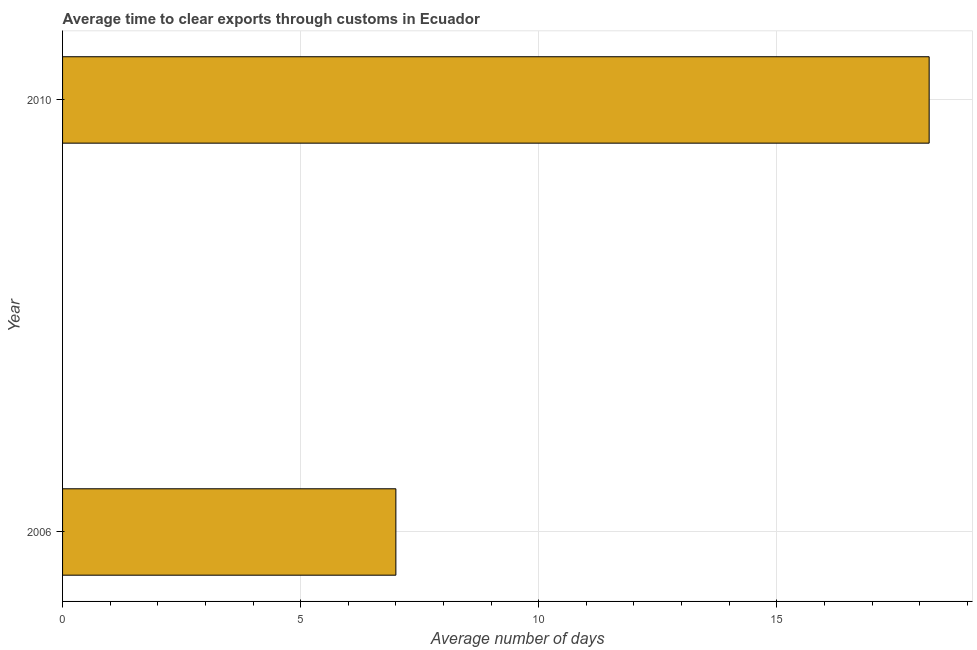Does the graph contain any zero values?
Make the answer very short. No. What is the title of the graph?
Keep it short and to the point. Average time to clear exports through customs in Ecuador. What is the label or title of the X-axis?
Give a very brief answer. Average number of days. Across all years, what is the maximum time to clear exports through customs?
Your answer should be compact. 18.2. In which year was the time to clear exports through customs minimum?
Make the answer very short. 2006. What is the sum of the time to clear exports through customs?
Provide a short and direct response. 25.2. What is the median time to clear exports through customs?
Your response must be concise. 12.6. In how many years, is the time to clear exports through customs greater than 16 days?
Give a very brief answer. 1. What is the ratio of the time to clear exports through customs in 2006 to that in 2010?
Provide a short and direct response. 0.39. Is the time to clear exports through customs in 2006 less than that in 2010?
Provide a succinct answer. Yes. How many bars are there?
Offer a very short reply. 2. What is the difference between two consecutive major ticks on the X-axis?
Offer a terse response. 5. Are the values on the major ticks of X-axis written in scientific E-notation?
Offer a very short reply. No. What is the Average number of days of 2006?
Offer a terse response. 7. What is the Average number of days in 2010?
Ensure brevity in your answer.  18.2. What is the difference between the Average number of days in 2006 and 2010?
Ensure brevity in your answer.  -11.2. What is the ratio of the Average number of days in 2006 to that in 2010?
Keep it short and to the point. 0.39. 